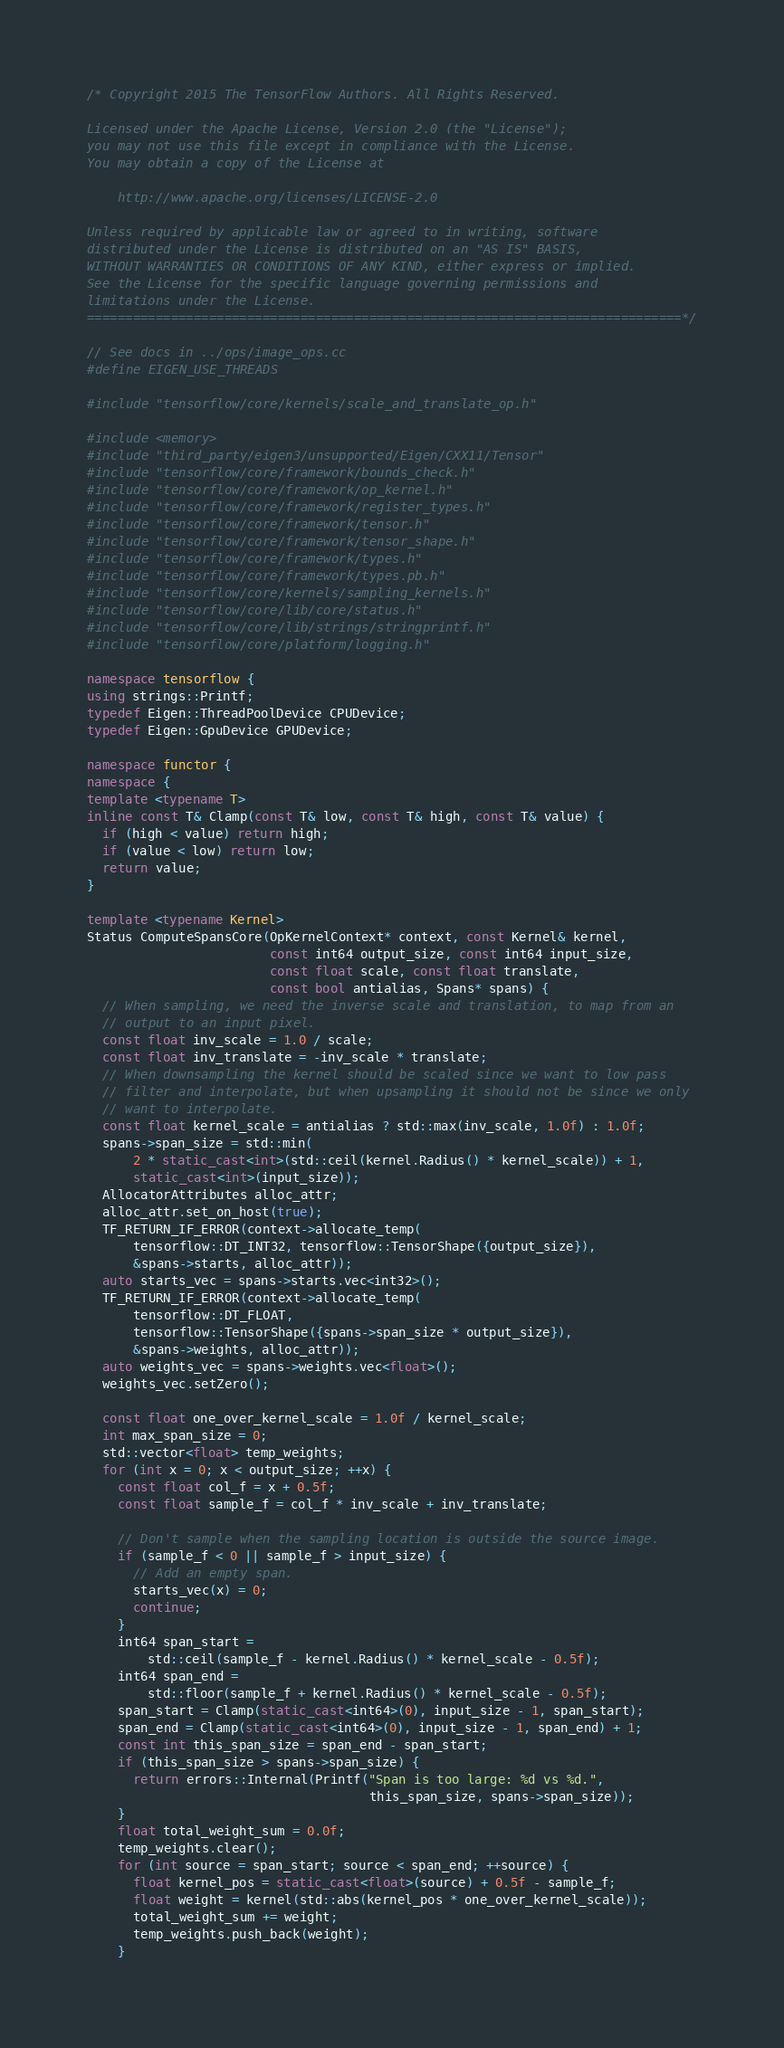Convert code to text. <code><loc_0><loc_0><loc_500><loc_500><_C++_>/* Copyright 2015 The TensorFlow Authors. All Rights Reserved.

Licensed under the Apache License, Version 2.0 (the "License");
you may not use this file except in compliance with the License.
You may obtain a copy of the License at

    http://www.apache.org/licenses/LICENSE-2.0

Unless required by applicable law or agreed to in writing, software
distributed under the License is distributed on an "AS IS" BASIS,
WITHOUT WARRANTIES OR CONDITIONS OF ANY KIND, either express or implied.
See the License for the specific language governing permissions and
limitations under the License.
==============================================================================*/

// See docs in ../ops/image_ops.cc
#define EIGEN_USE_THREADS

#include "tensorflow/core/kernels/scale_and_translate_op.h"

#include <memory>
#include "third_party/eigen3/unsupported/Eigen/CXX11/Tensor"
#include "tensorflow/core/framework/bounds_check.h"
#include "tensorflow/core/framework/op_kernel.h"
#include "tensorflow/core/framework/register_types.h"
#include "tensorflow/core/framework/tensor.h"
#include "tensorflow/core/framework/tensor_shape.h"
#include "tensorflow/core/framework/types.h"
#include "tensorflow/core/framework/types.pb.h"
#include "tensorflow/core/kernels/sampling_kernels.h"
#include "tensorflow/core/lib/core/status.h"
#include "tensorflow/core/lib/strings/stringprintf.h"
#include "tensorflow/core/platform/logging.h"

namespace tensorflow {
using strings::Printf;
typedef Eigen::ThreadPoolDevice CPUDevice;
typedef Eigen::GpuDevice GPUDevice;

namespace functor {
namespace {
template <typename T>
inline const T& Clamp(const T& low, const T& high, const T& value) {
  if (high < value) return high;
  if (value < low) return low;
  return value;
}

template <typename Kernel>
Status ComputeSpansCore(OpKernelContext* context, const Kernel& kernel,
                        const int64 output_size, const int64 input_size,
                        const float scale, const float translate,
                        const bool antialias, Spans* spans) {
  // When sampling, we need the inverse scale and translation, to map from an
  // output to an input pixel.
  const float inv_scale = 1.0 / scale;
  const float inv_translate = -inv_scale * translate;
  // When downsampling the kernel should be scaled since we want to low pass
  // filter and interpolate, but when upsampling it should not be since we only
  // want to interpolate.
  const float kernel_scale = antialias ? std::max(inv_scale, 1.0f) : 1.0f;
  spans->span_size = std::min(
      2 * static_cast<int>(std::ceil(kernel.Radius() * kernel_scale)) + 1,
      static_cast<int>(input_size));
  AllocatorAttributes alloc_attr;
  alloc_attr.set_on_host(true);
  TF_RETURN_IF_ERROR(context->allocate_temp(
      tensorflow::DT_INT32, tensorflow::TensorShape({output_size}),
      &spans->starts, alloc_attr));
  auto starts_vec = spans->starts.vec<int32>();
  TF_RETURN_IF_ERROR(context->allocate_temp(
      tensorflow::DT_FLOAT,
      tensorflow::TensorShape({spans->span_size * output_size}),
      &spans->weights, alloc_attr));
  auto weights_vec = spans->weights.vec<float>();
  weights_vec.setZero();

  const float one_over_kernel_scale = 1.0f / kernel_scale;
  int max_span_size = 0;
  std::vector<float> temp_weights;
  for (int x = 0; x < output_size; ++x) {
    const float col_f = x + 0.5f;
    const float sample_f = col_f * inv_scale + inv_translate;

    // Don't sample when the sampling location is outside the source image.
    if (sample_f < 0 || sample_f > input_size) {
      // Add an empty span.
      starts_vec(x) = 0;
      continue;
    }
    int64 span_start =
        std::ceil(sample_f - kernel.Radius() * kernel_scale - 0.5f);
    int64 span_end =
        std::floor(sample_f + kernel.Radius() * kernel_scale - 0.5f);
    span_start = Clamp(static_cast<int64>(0), input_size - 1, span_start);
    span_end = Clamp(static_cast<int64>(0), input_size - 1, span_end) + 1;
    const int this_span_size = span_end - span_start;
    if (this_span_size > spans->span_size) {
      return errors::Internal(Printf("Span is too large: %d vs %d.",
                                     this_span_size, spans->span_size));
    }
    float total_weight_sum = 0.0f;
    temp_weights.clear();
    for (int source = span_start; source < span_end; ++source) {
      float kernel_pos = static_cast<float>(source) + 0.5f - sample_f;
      float weight = kernel(std::abs(kernel_pos * one_over_kernel_scale));
      total_weight_sum += weight;
      temp_weights.push_back(weight);
    }</code> 